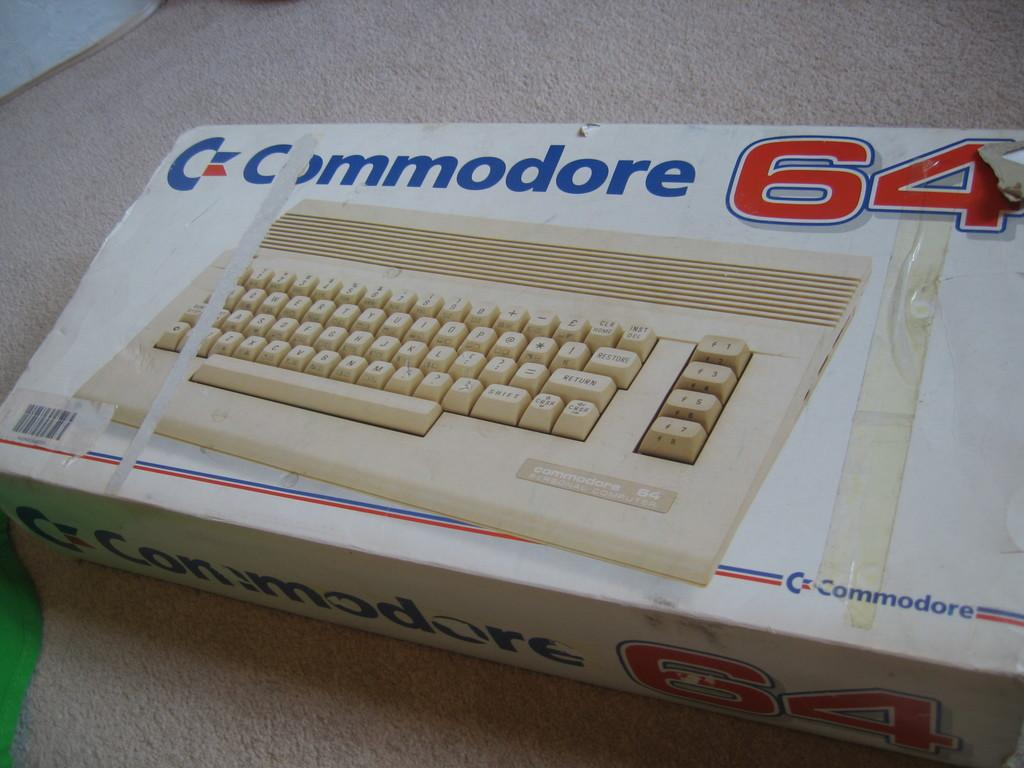<image>
Relay a brief, clear account of the picture shown. a box with a keyboard picture on it that looks old and taped, brand name is Commodore 64. 